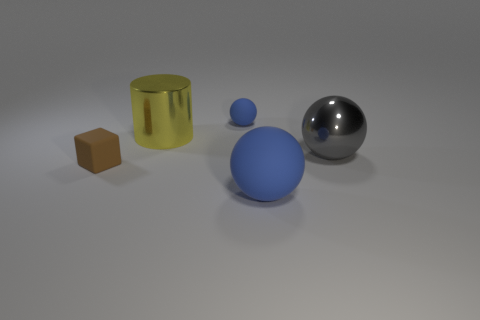There is a gray thing; what number of yellow shiny objects are to the left of it?
Ensure brevity in your answer.  1. Is the sphere that is to the left of the large blue object made of the same material as the sphere to the right of the big rubber object?
Keep it short and to the point. No. There is a blue rubber thing that is behind the big ball to the left of the big sphere on the right side of the large rubber sphere; what is its shape?
Give a very brief answer. Sphere. The large gray metallic thing has what shape?
Offer a terse response. Sphere. What shape is the other rubber thing that is the same size as the brown object?
Keep it short and to the point. Sphere. What number of other things are the same color as the metal cylinder?
Offer a very short reply. 0. Does the blue rubber thing that is in front of the brown matte cube have the same shape as the matte object behind the brown thing?
Make the answer very short. Yes. How many things are either objects in front of the big metal cylinder or blue spheres that are behind the gray metallic ball?
Offer a terse response. 4. What number of other things are the same material as the large blue ball?
Make the answer very short. 2. Are the cylinder on the left side of the tiny matte sphere and the large blue sphere made of the same material?
Ensure brevity in your answer.  No. 